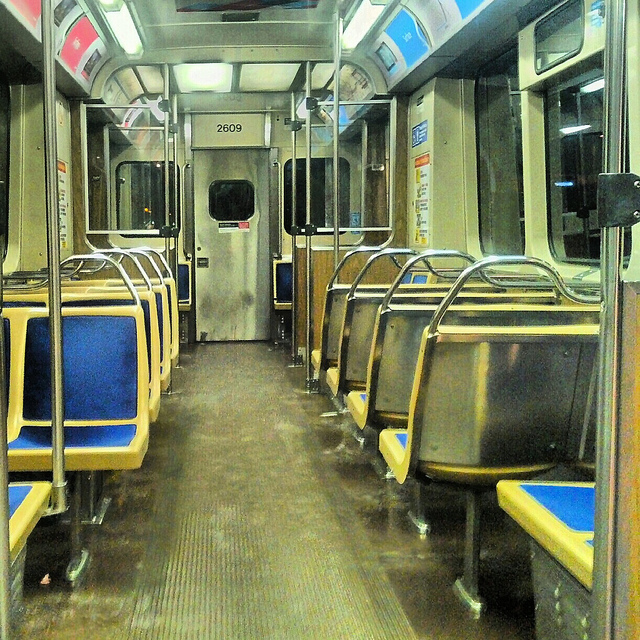Identify the text contained in this image. 2609 